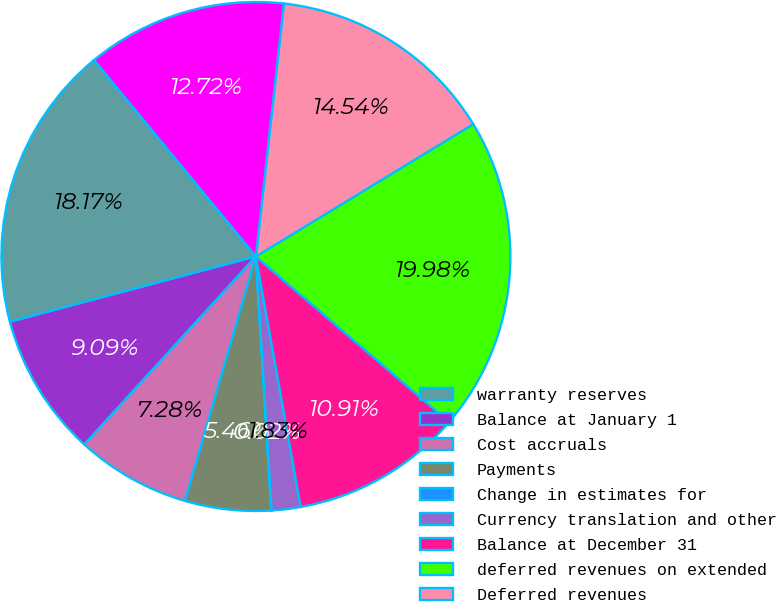Convert chart. <chart><loc_0><loc_0><loc_500><loc_500><pie_chart><fcel>warranty reserves<fcel>Balance at January 1<fcel>Cost accruals<fcel>Payments<fcel>Change in estimates for<fcel>Currency translation and other<fcel>Balance at December 31<fcel>deferred revenues on extended<fcel>Deferred revenues<fcel>Revenues recognized<nl><fcel>18.17%<fcel>9.09%<fcel>7.28%<fcel>5.46%<fcel>0.02%<fcel>1.83%<fcel>10.91%<fcel>19.98%<fcel>14.54%<fcel>12.72%<nl></chart> 